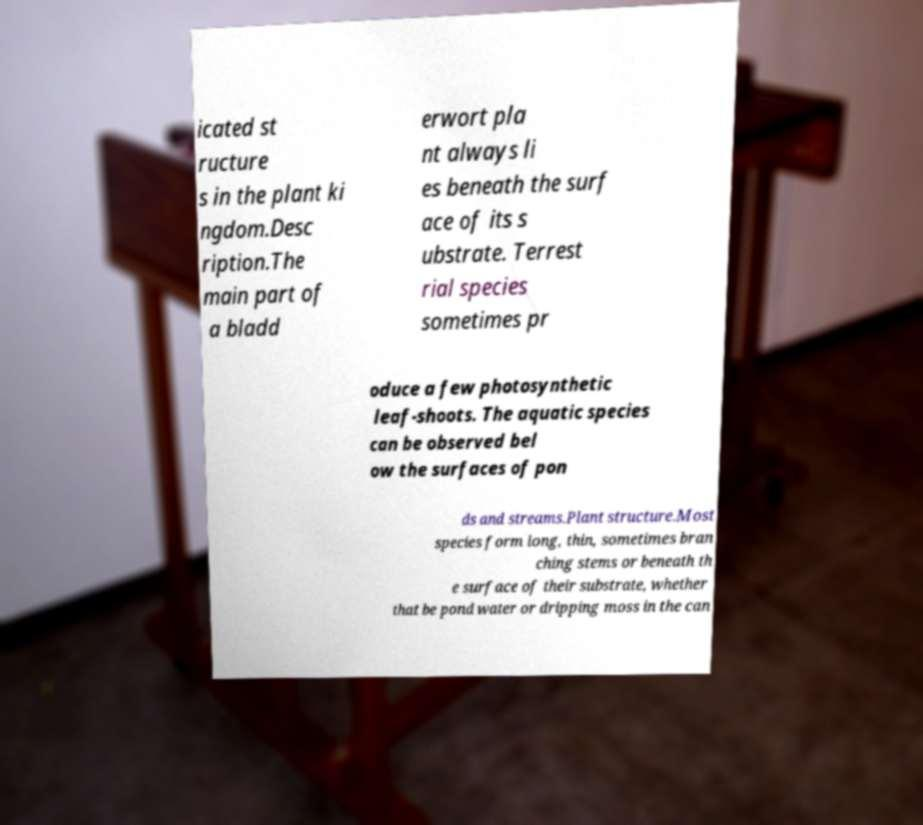What messages or text are displayed in this image? I need them in a readable, typed format. icated st ructure s in the plant ki ngdom.Desc ription.The main part of a bladd erwort pla nt always li es beneath the surf ace of its s ubstrate. Terrest rial species sometimes pr oduce a few photosynthetic leaf-shoots. The aquatic species can be observed bel ow the surfaces of pon ds and streams.Plant structure.Most species form long, thin, sometimes bran ching stems or beneath th e surface of their substrate, whether that be pond water or dripping moss in the can 